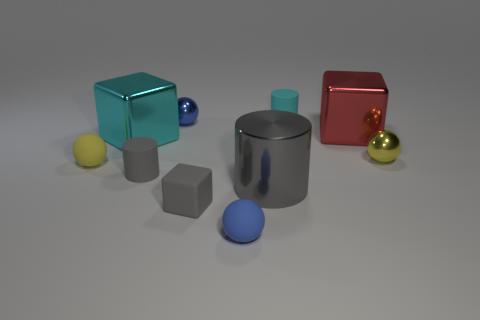How many yellow spheres must be subtracted to get 1 yellow spheres? 1 Subtract all small rubber cylinders. How many cylinders are left? 1 Subtract all blue cylinders. How many yellow balls are left? 2 Subtract 3 spheres. How many spheres are left? 1 Subtract all cubes. How many objects are left? 7 Subtract all red cylinders. Subtract all tiny yellow rubber things. How many objects are left? 9 Add 6 tiny shiny objects. How many tiny shiny objects are left? 8 Add 10 big blue rubber spheres. How many big blue rubber spheres exist? 10 Subtract 0 cyan spheres. How many objects are left? 10 Subtract all brown cubes. Subtract all green cylinders. How many cubes are left? 3 